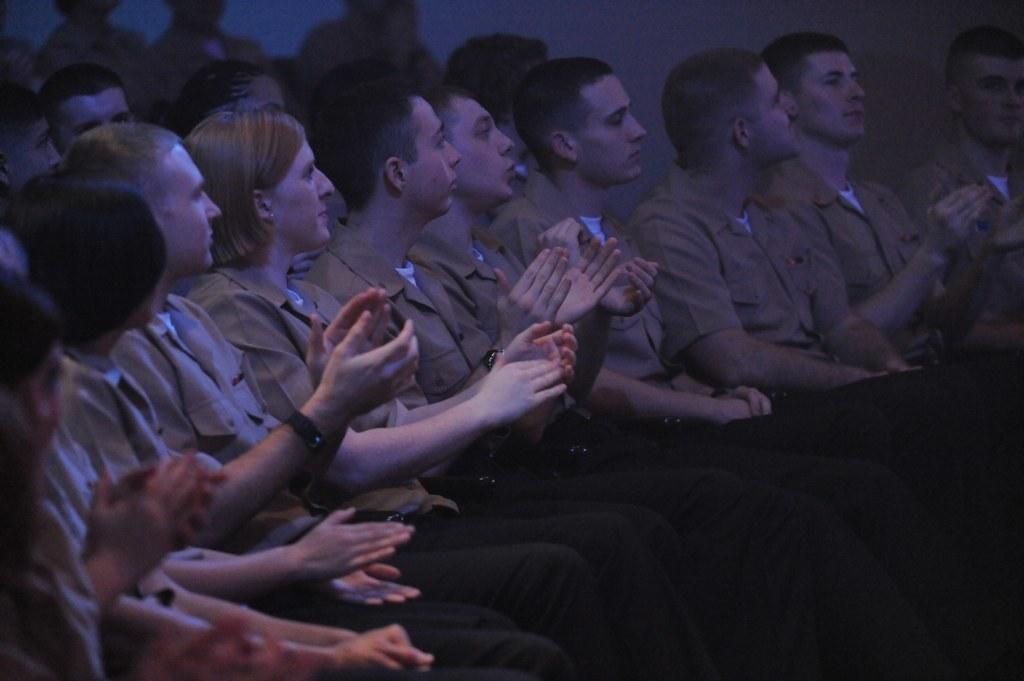Who or what can be seen in the image? There are people in the image. What are the people doing in the image? The people are sitting on chairs. What shape is the soap taking in the image? There is no soap present in the image. 